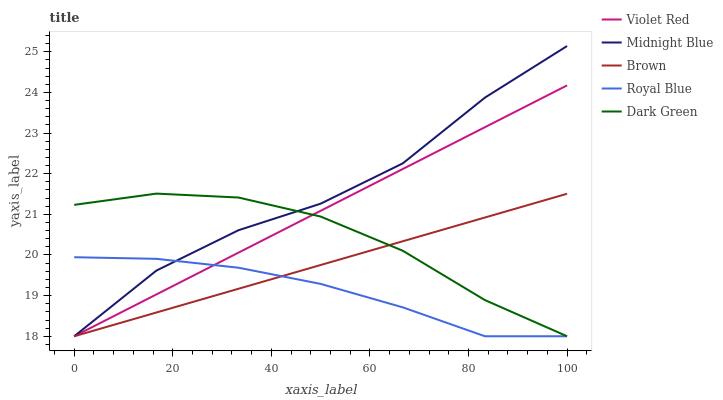Does Royal Blue have the minimum area under the curve?
Answer yes or no. Yes. Does Midnight Blue have the maximum area under the curve?
Answer yes or no. Yes. Does Violet Red have the minimum area under the curve?
Answer yes or no. No. Does Violet Red have the maximum area under the curve?
Answer yes or no. No. Is Violet Red the smoothest?
Answer yes or no. Yes. Is Midnight Blue the roughest?
Answer yes or no. Yes. Is Dark Green the smoothest?
Answer yes or no. No. Is Dark Green the roughest?
Answer yes or no. No. Does Brown have the lowest value?
Answer yes or no. Yes. Does Midnight Blue have the highest value?
Answer yes or no. Yes. Does Violet Red have the highest value?
Answer yes or no. No. Does Dark Green intersect Brown?
Answer yes or no. Yes. Is Dark Green less than Brown?
Answer yes or no. No. Is Dark Green greater than Brown?
Answer yes or no. No. 